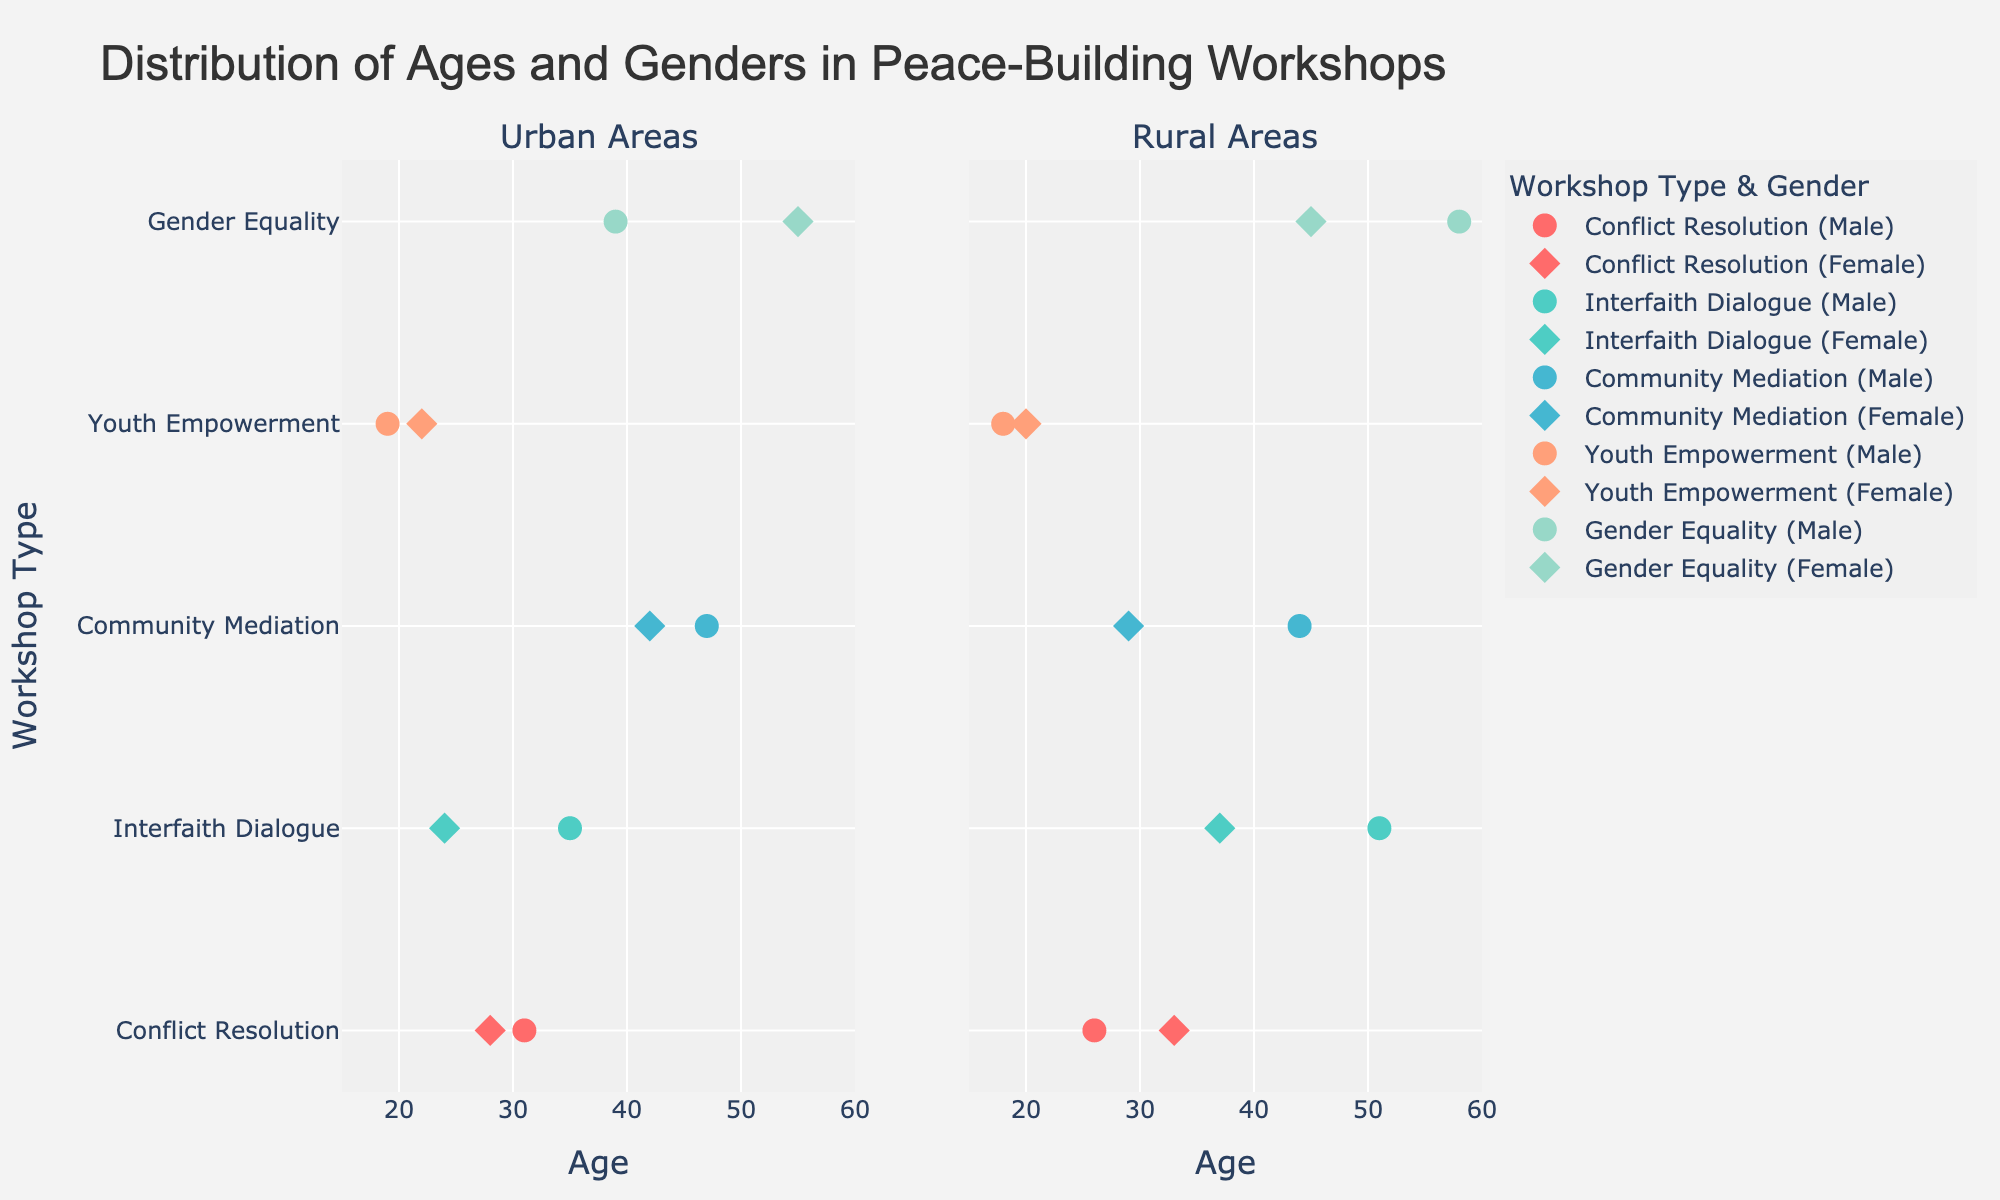What is the title of the figure? The title of the figure is typically located at the top and it describes the main subject of the plot. In this case, it is "Distribution of Ages and Genders in Peace-Building Workshops".
Answer: Distribution of Ages and Genders in Peace-Building Workshops What are the subplot titles? Each subplot usually has a title that is located at the top of the subplot and describes the segment of data being represented. Here, the subplots are titled "Urban Areas" and "Rural Areas".
Answer: Urban Areas; Rural Areas How are the genders represented visually in the figure? In scatter plots, different symbols or shapes are often used to distinguish different categories. Here, males are represented by circles, and females are represented by diamonds.
Answer: Circles (Male); Diamonds (Female) What color represents the 'Conflict Resolution' workshop? Each workshop type is typically color-coded for easy identification. 'Conflict Resolution' is represented by the color red.
Answer: Red Which workshop type has the oldest attendee in urban areas? To determine the oldest attendee in urban areas from the scatter plot on the left, we look for the data point farthest to the right. For urban areas, 'Gender Equality' has the attendee aged 55.
Answer: Gender Equality How many workshops in total are held in rural areas? We can count the number of unique workshop types indicated by different colors and legend entries in the rural subplot. The workshops are 'Conflict Resolution', 'Interfaith Dialogue', 'Community Mediation', 'Youth Empowerment', and 'Gender Equality', summing to 5.
Answer: 5 What is the age range for attendees in 'Youth Empowerment' workshops in rural areas? To find the age range, identify the youngest and oldest attendees in the 'Youth Empowerment' category in the rural subplot. The ages range from 18 to 20 years.
Answer: 18-20 Do urban or rural areas have a wider range of ages for 'Community Mediation' workshops? We need to determine the range of ages for 'Community Mediation' in both subplots. In urban areas, the ages range from 28 to 42, a span of 14 years. In rural areas, the ages range from 29 to 44, a span of 15 years. Thus, rural areas have a slightly wider range.
Answer: Rural areas Which gender has a higher average age in 'Interfaith Dialogue' workshops in urban areas? To find the average age for each gender in 'Interfaith Dialogue' workshops in urban areas, calculate: Males = (35) / 1 = 35, Females = (24) / 1 = 24, resulting in males having a higher average age.
Answer: Males Is there a workshop type where the gender distribution is equal in rural areas? Equal gender distribution implies an equal number of male and female attendees for a workshop type. By visual inspection, 'Youth Empowerment' and 'Gender Equality' have equal representation of each gender (one male and one female each).
Answer: Youth Empowerment; Gender Equality 